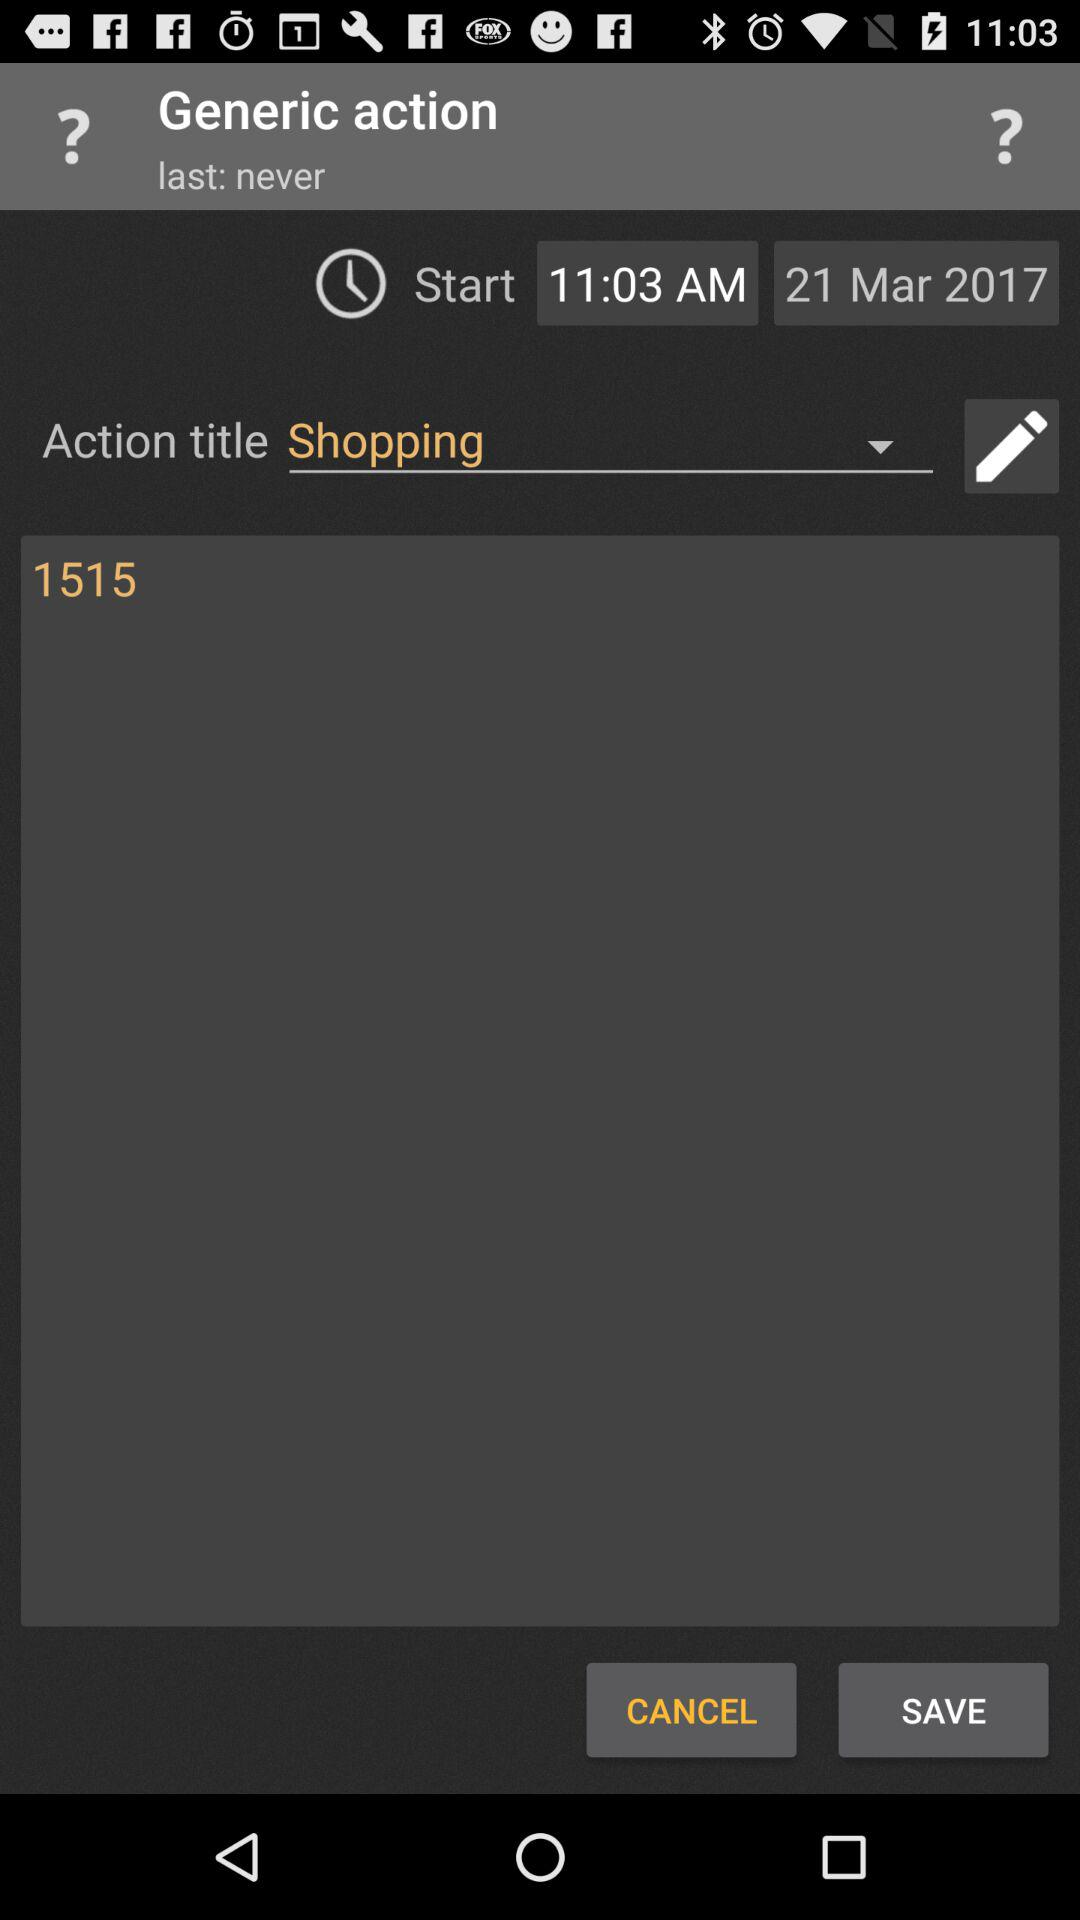What is the selected action title? The selected action title is "Shopping". 